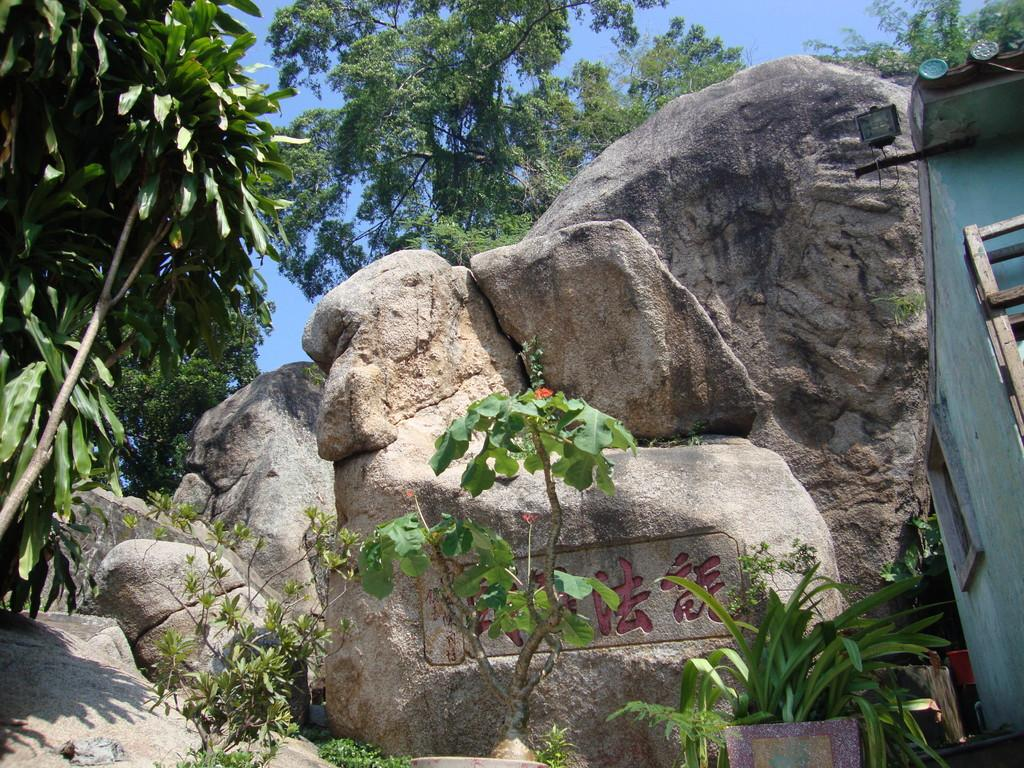What type of vegetation can be seen in the image? There are potted plants, a rock, and trees in the image. Where is the house located in the image? The house is on the right side of the image. What is the color of the sky in the image? The sky is blue in color. Can you see a person walking a dog in the image? There is no person or dog present in the image. What type of shoes is the person wearing in the image? There is no person in the image, so it is not possible to determine what type of shoes they might be wearing. 